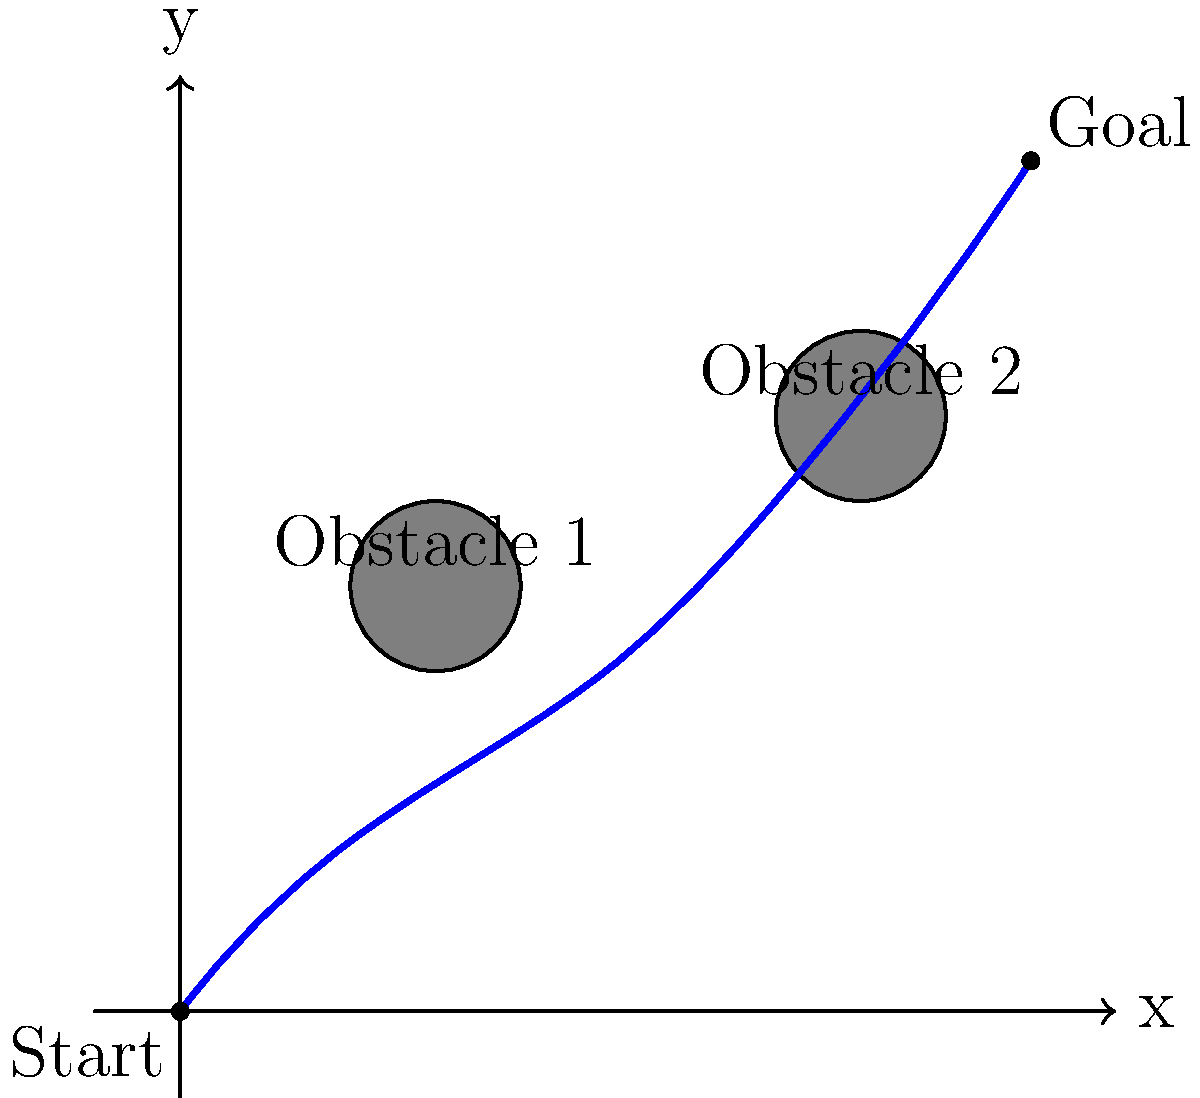A robot needs to navigate from the start point (0,0) to the goal point (10,10) while avoiding two circular obstacles centered at (3,5) and (8,7), each with a radius of 1 unit. The robot can move in any direction, but it must maintain a minimum distance of 0.5 units from the edge of each obstacle. Determine the length of the shortest path that satisfies these conditions, assuming the robot follows a smooth curve composed of circular arcs and straight lines. To solve this problem, we'll follow these steps:

1) First, we need to understand that the shortest path will be tangent to the expanded obstacles (with radius 1.5 units each, due to the 0.5 unit minimum distance requirement).

2) The path will consist of:
   - A straight line from (0,0) to the tangent point of the first expanded obstacle
   - An arc around the first expanded obstacle
   - A straight line between the two expanded obstacles
   - An arc around the second expanded obstacle
   - A straight line from the second expanded obstacle to (10,10)

3) To calculate this, we need to:
   a) Find the tangent points on each expanded obstacle
   b) Calculate the length of each straight line segment
   c) Calculate the length of each arc

4) For the first obstacle:
   - Center: (3,5), Radius: 1.5
   - Tangent points: Approximately (1.8, 2.7) and (4.2, 7.3)

5) For the second obstacle:
   - Center: (8,7), Radius: 1.5
   - Tangent points: Approximately (6.7, 6.1) and (9.3, 7.9)

6) Length of straight line segments:
   - Start to first obstacle: $\sqrt{(1.8-0)^2 + (2.7-0)^2} \approx 3.24$
   - Between obstacles: $\sqrt{(6.7-4.2)^2 + (6.1-7.3)^2} \approx 2.69$
   - Second obstacle to goal: $\sqrt{(10-9.3)^2 + (10-7.9)^2} \approx 2.33$

7) Length of arcs:
   - First obstacle: $1.5 \cdot \arctan(\frac{7.3-2.7}{4.2-1.8}) \approx 2.36$
   - Second obstacle: $1.5 \cdot \arctan(\frac{7.9-6.1}{9.3-6.7}) \approx 1.35$

8) Total path length:
   $3.24 + 2.36 + 2.69 + 1.35 + 2.33 \approx 11.97$

Therefore, the length of the shortest path is approximately 11.97 units.
Answer: 11.97 units 